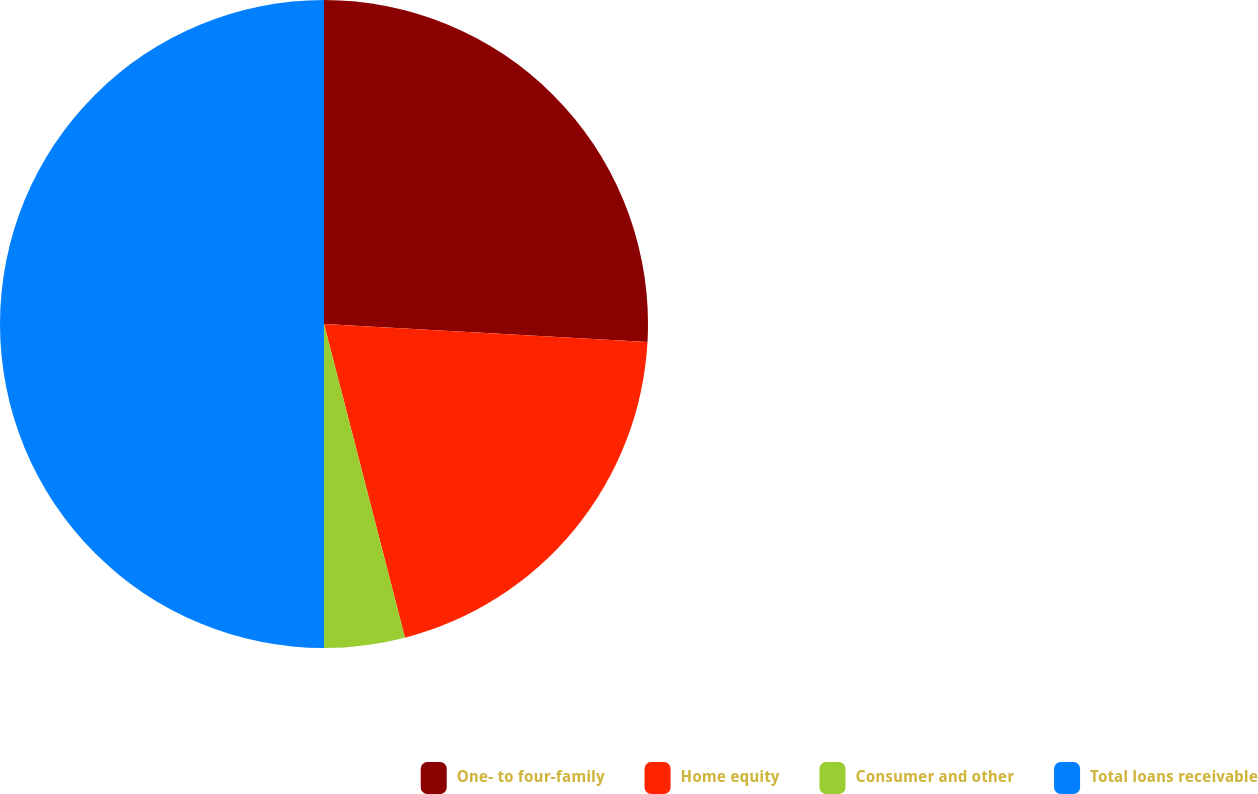Convert chart to OTSL. <chart><loc_0><loc_0><loc_500><loc_500><pie_chart><fcel>One- to four-family<fcel>Home equity<fcel>Consumer and other<fcel>Total loans receivable<nl><fcel>25.89%<fcel>20.09%<fcel>4.02%<fcel>50.0%<nl></chart> 